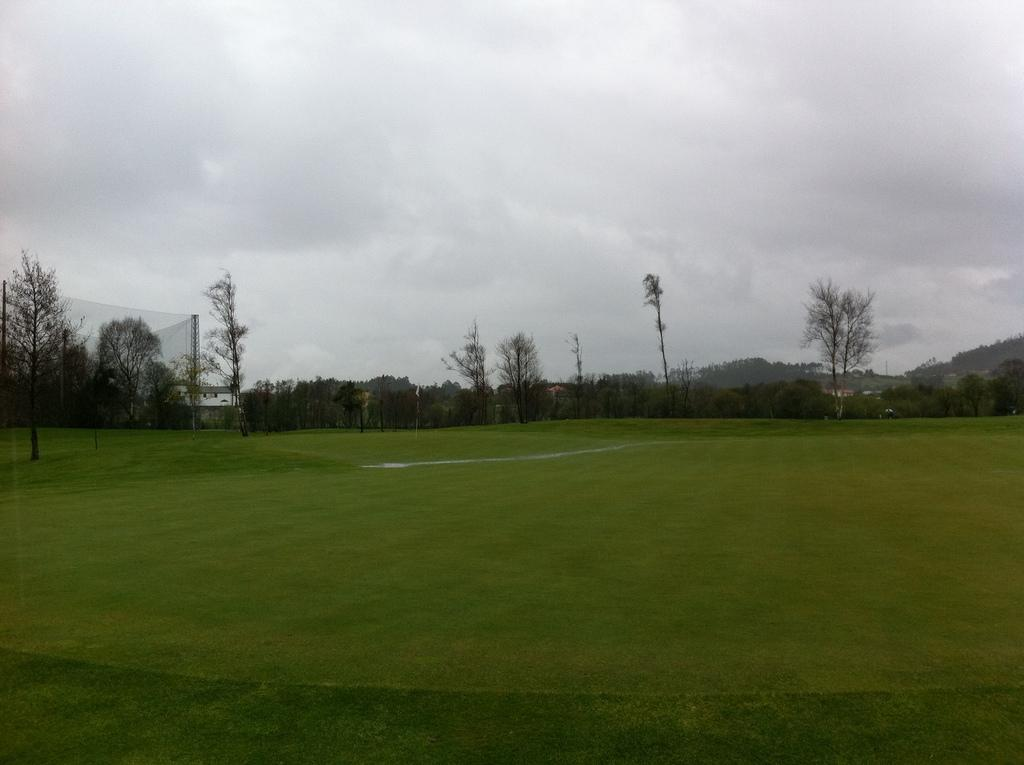What type of terrain is shown in the image? The image depicts a grassy land. What can be seen on the left side of the image? There is a mesh on the left side of the image. What is visible in the background of the image? Trees are visible in the background of the image. What is visible at the top of the image? The sky is visible at the top of the image. What can be seen in the sky? Clouds are present in the sky. How many lizards are crawling on the mesh in the image? There are no lizards present in the image; it only features a grassy land, a mesh, trees, sky, and clouds. 